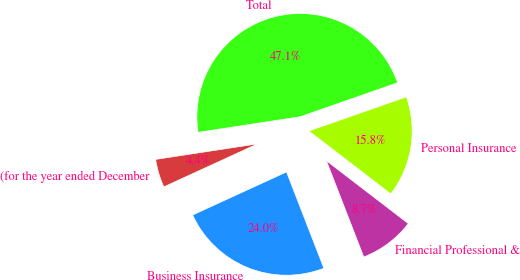<chart> <loc_0><loc_0><loc_500><loc_500><pie_chart><fcel>(for the year ended December<fcel>Business Insurance<fcel>Financial Professional &<fcel>Personal Insurance<fcel>Total<nl><fcel>4.43%<fcel>24.05%<fcel>8.69%<fcel>15.77%<fcel>47.06%<nl></chart> 